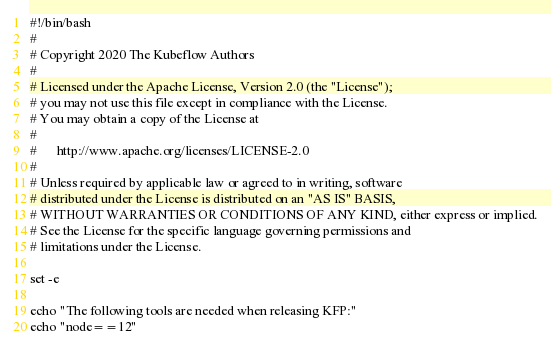<code> <loc_0><loc_0><loc_500><loc_500><_Bash_>#!/bin/bash
#
# Copyright 2020 The Kubeflow Authors
#
# Licensed under the Apache License, Version 2.0 (the "License");
# you may not use this file except in compliance with the License.
# You may obtain a copy of the License at
#
#      http://www.apache.org/licenses/LICENSE-2.0
#
# Unless required by applicable law or agreed to in writing, software
# distributed under the License is distributed on an "AS IS" BASIS,
# WITHOUT WARRANTIES OR CONDITIONS OF ANY KIND, either express or implied.
# See the License for the specific language governing permissions and
# limitations under the License.

set -e

echo "The following tools are needed when releasing KFP:"
echo "node==12"</code> 